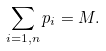<formula> <loc_0><loc_0><loc_500><loc_500>\sum _ { i = 1 , n } p _ { i } = M .</formula> 